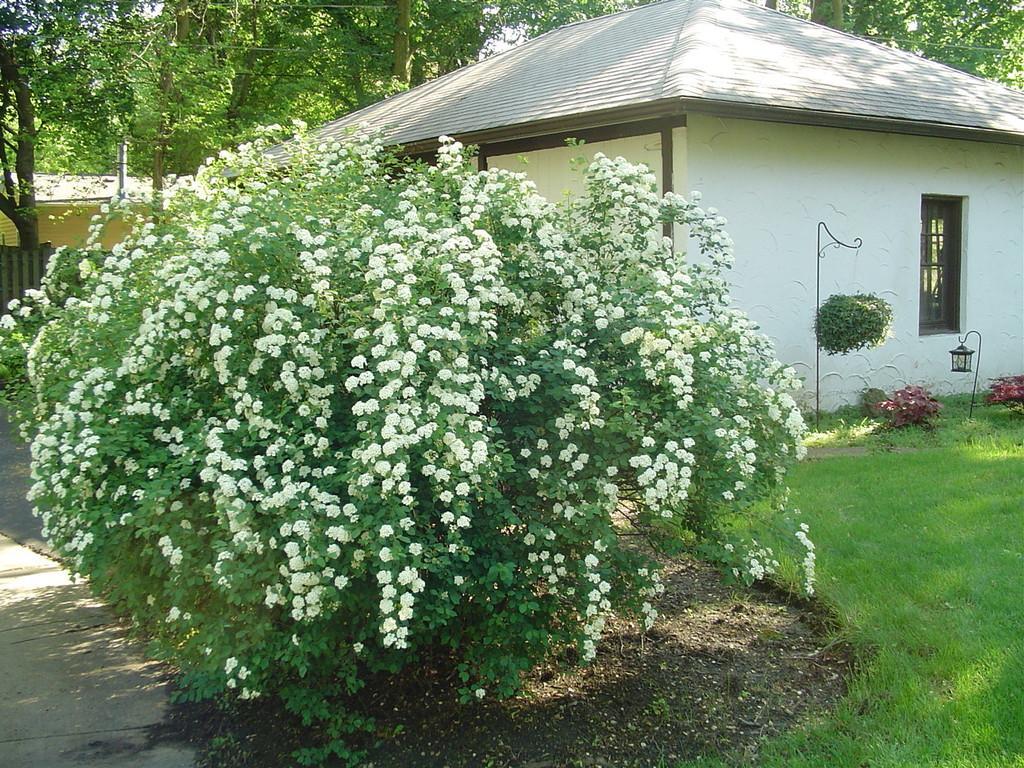How would you summarize this image in a sentence or two? In this given picture, We can see a house which is build with window a tree filled with white color flowers and a grass, tiny trees after that i can see a iron metal and tree which is hanging to it and behind this house, We can see few trees. 